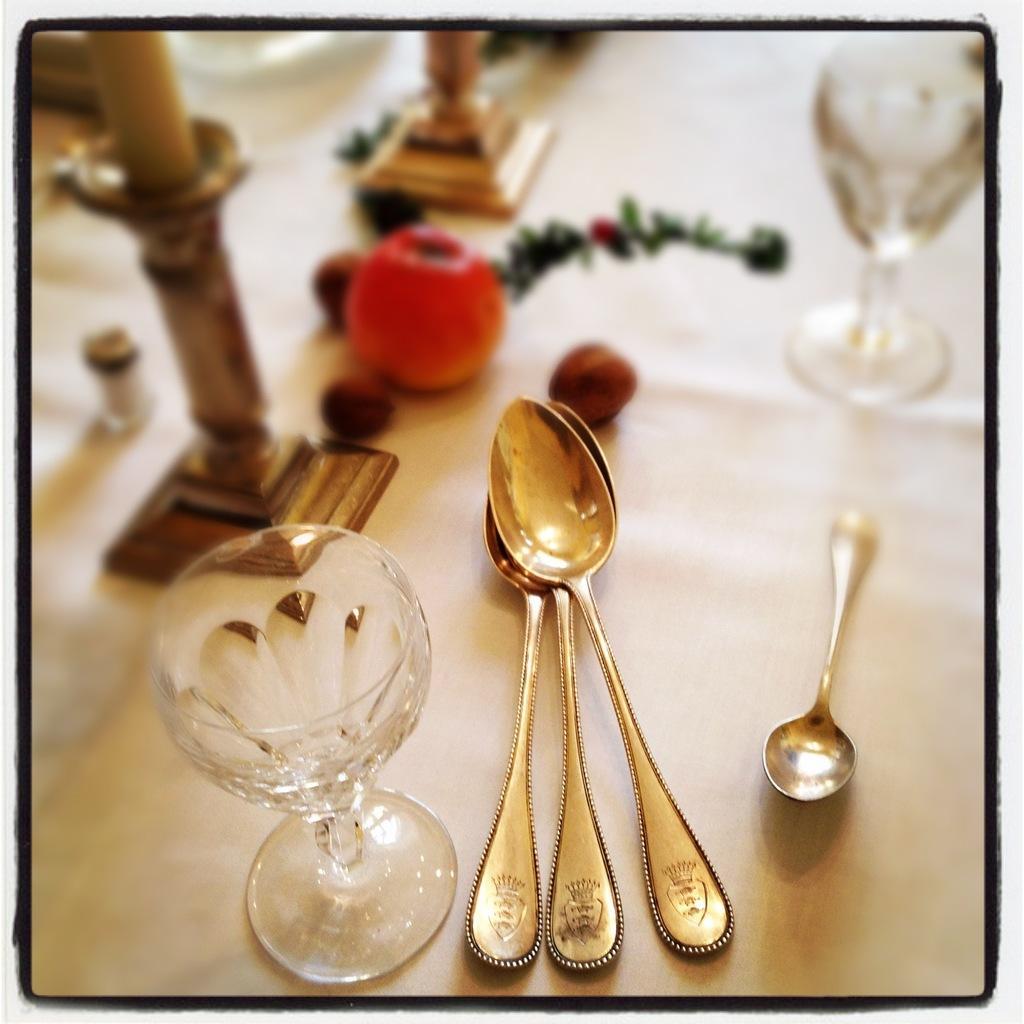In one or two sentences, can you explain what this image depicts? In this picture, we see the glasses, spoons, fruit and some other objects are placed on the table. This table is covered with the white color cloth. This picture might be a photo frame. 